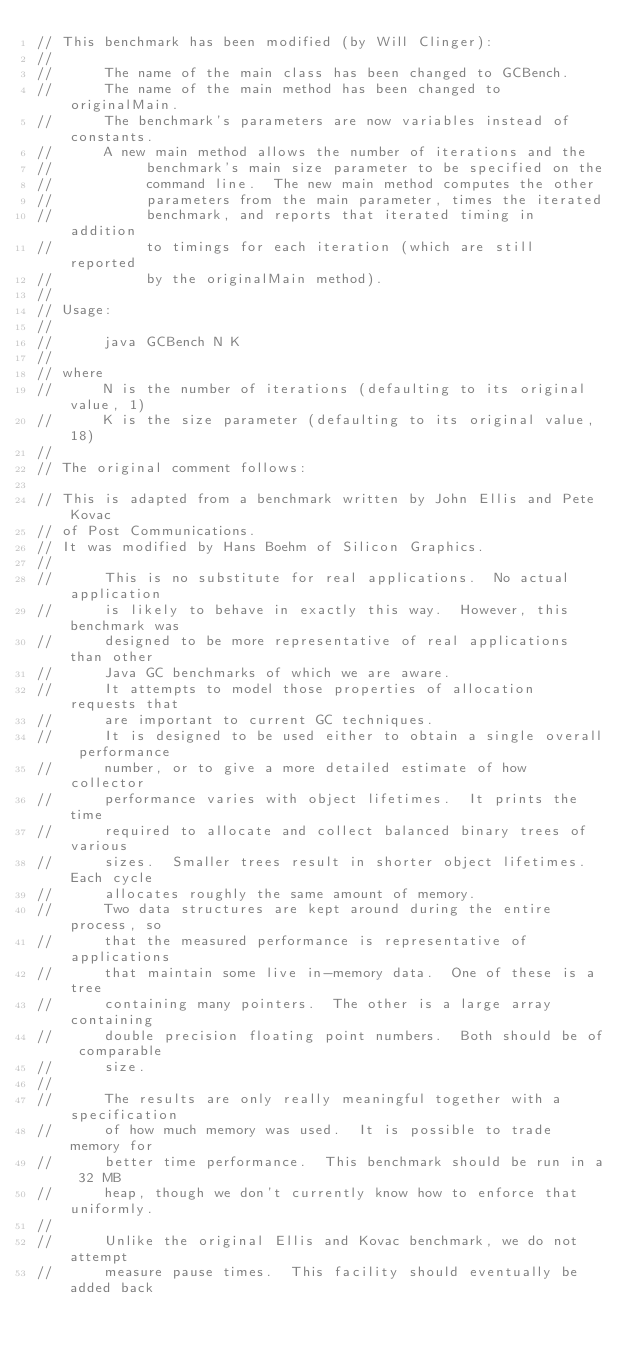<code> <loc_0><loc_0><loc_500><loc_500><_Java_>// This benchmark has been modified (by Will Clinger):
//
//      The name of the main class has been changed to GCBench.
//      The name of the main method has been changed to originalMain.
//      The benchmark's parameters are now variables instead of constants.
//      A new main method allows the number of iterations and the
//           benchmark's main size parameter to be specified on the
//           command line.  The new main method computes the other
//           parameters from the main parameter, times the iterated
//           benchmark, and reports that iterated timing in addition
//           to timings for each iteration (which are still reported
//           by the originalMain method).
//
// Usage:
//
//      java GCBench N K
//
// where
//      N is the number of iterations (defaulting to its original value, 1)
//      K is the size parameter (defaulting to its original value, 18)
//
// The original comment follows:

// This is adapted from a benchmark written by John Ellis and Pete Kovac
// of Post Communications.
// It was modified by Hans Boehm of Silicon Graphics.
//
//      This is no substitute for real applications.  No actual application
//      is likely to behave in exactly this way.  However, this benchmark was
//      designed to be more representative of real applications than other
//      Java GC benchmarks of which we are aware.
//      It attempts to model those properties of allocation requests that
//      are important to current GC techniques.
//      It is designed to be used either to obtain a single overall performance
//      number, or to give a more detailed estimate of how collector
//      performance varies with object lifetimes.  It prints the time
//      required to allocate and collect balanced binary trees of various
//      sizes.  Smaller trees result in shorter object lifetimes.  Each cycle
//      allocates roughly the same amount of memory.
//      Two data structures are kept around during the entire process, so
//      that the measured performance is representative of applications
//      that maintain some live in-memory data.  One of these is a tree
//      containing many pointers.  The other is a large array containing
//      double precision floating point numbers.  Both should be of comparable
//      size.
//
//      The results are only really meaningful together with a specification
//      of how much memory was used.  It is possible to trade memory for
//      better time performance.  This benchmark should be run in a 32 MB
//      heap, though we don't currently know how to enforce that uniformly.
//
//      Unlike the original Ellis and Kovac benchmark, we do not attempt
//      measure pause times.  This facility should eventually be added back</code> 